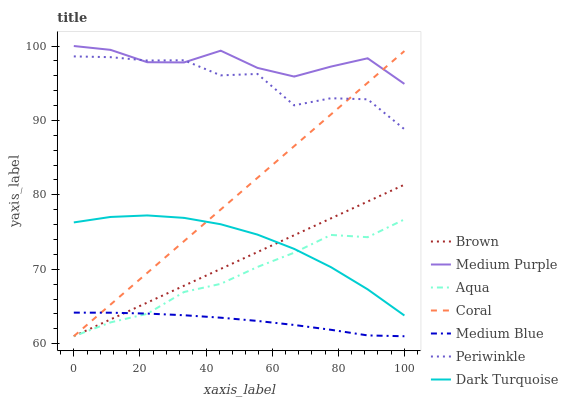Does Coral have the minimum area under the curve?
Answer yes or no. No. Does Coral have the maximum area under the curve?
Answer yes or no. No. Is Medium Blue the smoothest?
Answer yes or no. No. Is Medium Blue the roughest?
Answer yes or no. No. Does Medium Purple have the lowest value?
Answer yes or no. No. Does Coral have the highest value?
Answer yes or no. No. Is Medium Blue less than Medium Purple?
Answer yes or no. Yes. Is Medium Purple greater than Aqua?
Answer yes or no. Yes. Does Medium Blue intersect Medium Purple?
Answer yes or no. No. 